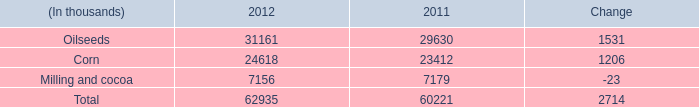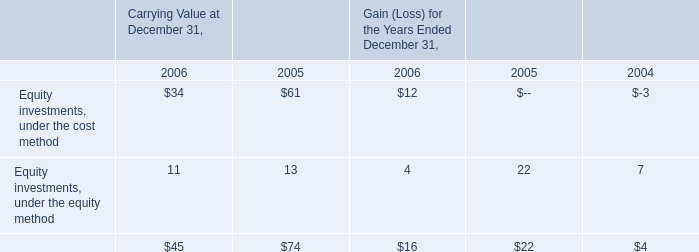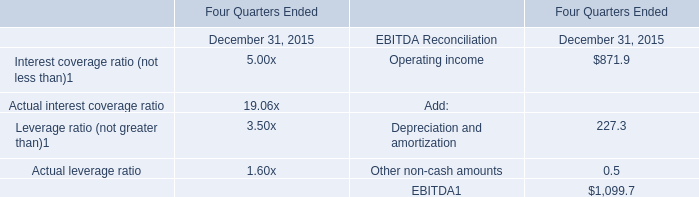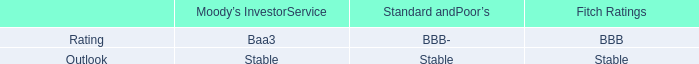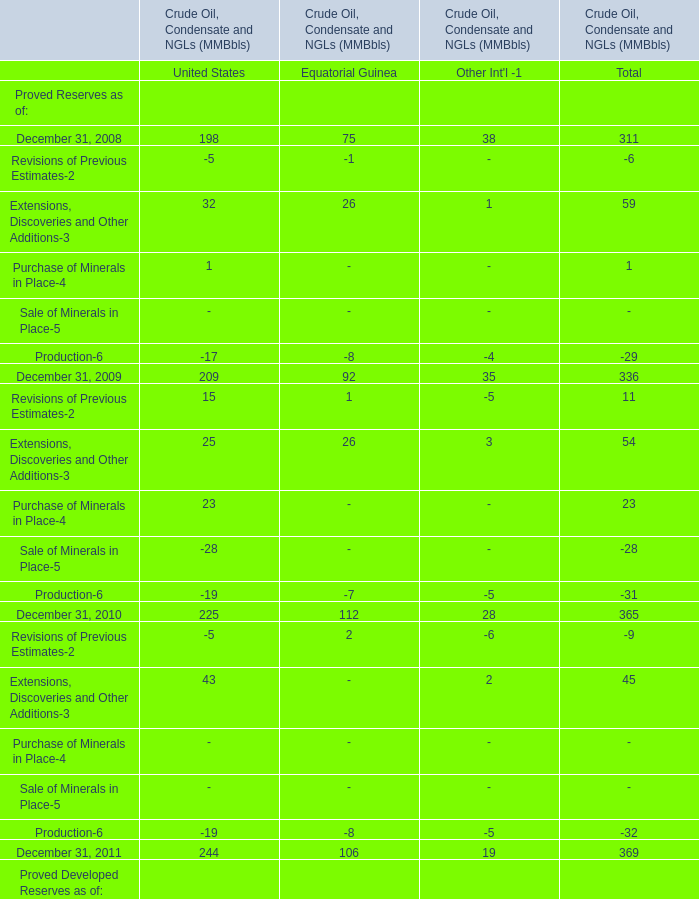Which year is Proved Developed Reserves as of United State the least? 
Answer: 2010. 